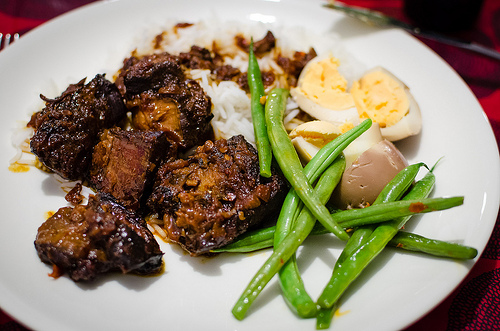<image>
Can you confirm if the beans is under the eggs? No. The beans is not positioned under the eggs. The vertical relationship between these objects is different. 